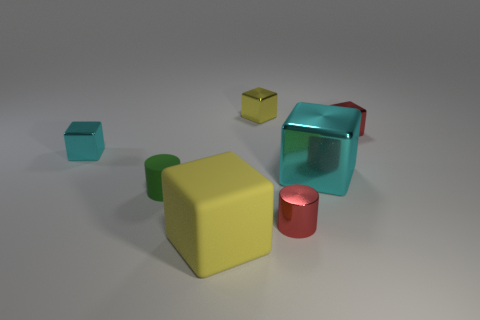Subtract 2 cubes. How many cubes are left? 3 Subtract all large cyan metallic cubes. How many cubes are left? 4 Subtract all blue cubes. Subtract all red cylinders. How many cubes are left? 5 Add 2 large rubber things. How many objects exist? 9 Subtract all cylinders. How many objects are left? 5 Subtract 0 gray cylinders. How many objects are left? 7 Subtract all green rubber things. Subtract all small green matte things. How many objects are left? 5 Add 3 red blocks. How many red blocks are left? 4 Add 5 small red things. How many small red things exist? 7 